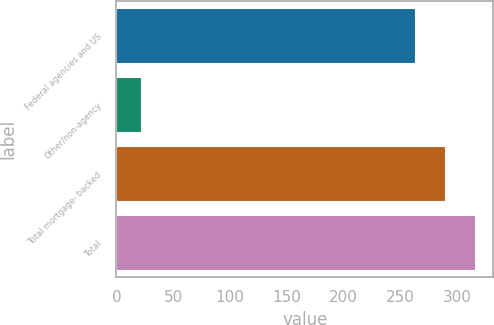Convert chart to OTSL. <chart><loc_0><loc_0><loc_500><loc_500><bar_chart><fcel>Federal agencies and US<fcel>Other/non-agency<fcel>Total mortgage- backed<fcel>Total<nl><fcel>263<fcel>22<fcel>289.4<fcel>315.8<nl></chart> 